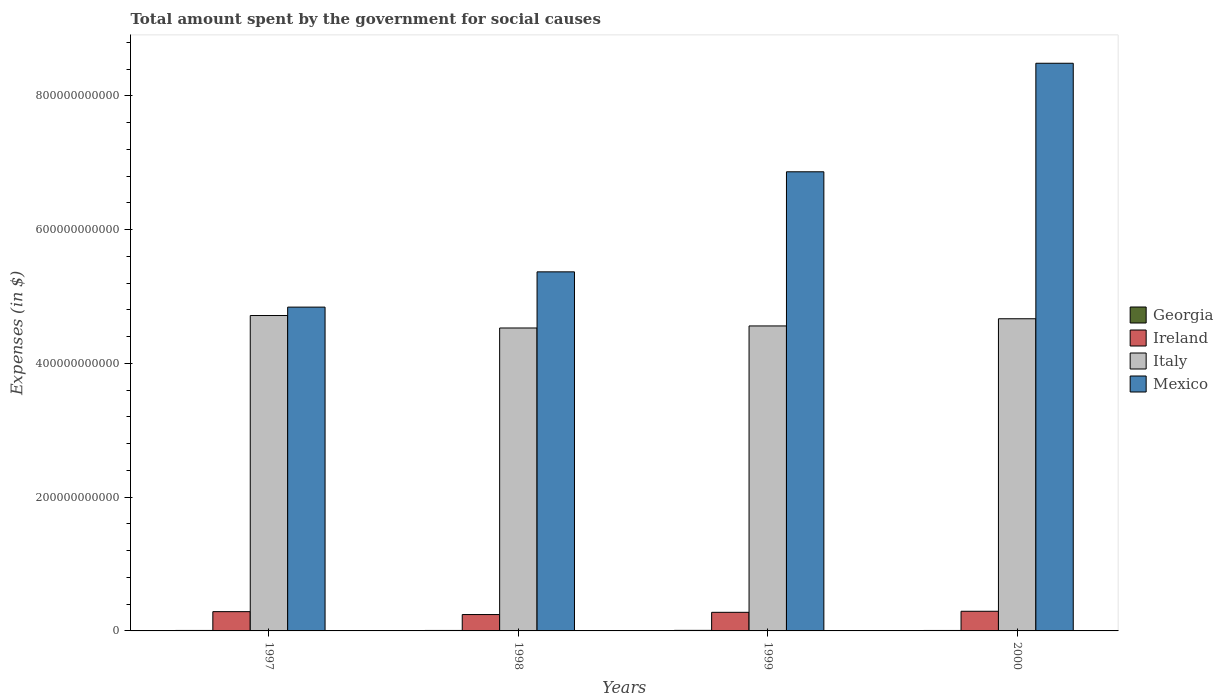How many different coloured bars are there?
Offer a very short reply. 4. How many groups of bars are there?
Offer a terse response. 4. How many bars are there on the 4th tick from the left?
Your response must be concise. 4. How many bars are there on the 3rd tick from the right?
Ensure brevity in your answer.  4. What is the label of the 1st group of bars from the left?
Your answer should be compact. 1997. In how many cases, is the number of bars for a given year not equal to the number of legend labels?
Provide a succinct answer. 0. What is the amount spent for social causes by the government in Italy in 1997?
Your answer should be compact. 4.72e+11. Across all years, what is the maximum amount spent for social causes by the government in Mexico?
Give a very brief answer. 8.49e+11. Across all years, what is the minimum amount spent for social causes by the government in Mexico?
Provide a succinct answer. 4.84e+11. In which year was the amount spent for social causes by the government in Ireland minimum?
Your response must be concise. 1998. What is the total amount spent for social causes by the government in Georgia in the graph?
Your answer should be very brief. 2.94e+09. What is the difference between the amount spent for social causes by the government in Italy in 1997 and that in 2000?
Offer a terse response. 4.85e+09. What is the difference between the amount spent for social causes by the government in Italy in 1998 and the amount spent for social causes by the government in Mexico in 1999?
Your answer should be compact. -2.34e+11. What is the average amount spent for social causes by the government in Georgia per year?
Offer a very short reply. 7.34e+08. In the year 2000, what is the difference between the amount spent for social causes by the government in Italy and amount spent for social causes by the government in Ireland?
Make the answer very short. 4.37e+11. In how many years, is the amount spent for social causes by the government in Italy greater than 40000000000 $?
Your answer should be compact. 4. What is the ratio of the amount spent for social causes by the government in Italy in 1997 to that in 1999?
Make the answer very short. 1.03. Is the amount spent for social causes by the government in Ireland in 1997 less than that in 1999?
Provide a succinct answer. No. Is the difference between the amount spent for social causes by the government in Italy in 1998 and 2000 greater than the difference between the amount spent for social causes by the government in Ireland in 1998 and 2000?
Provide a short and direct response. No. What is the difference between the highest and the second highest amount spent for social causes by the government in Mexico?
Keep it short and to the point. 1.62e+11. What is the difference between the highest and the lowest amount spent for social causes by the government in Mexico?
Offer a terse response. 3.65e+11. In how many years, is the amount spent for social causes by the government in Mexico greater than the average amount spent for social causes by the government in Mexico taken over all years?
Offer a very short reply. 2. What does the 3rd bar from the right in 1999 represents?
Your answer should be compact. Ireland. How many bars are there?
Provide a short and direct response. 16. Are all the bars in the graph horizontal?
Your answer should be very brief. No. How many years are there in the graph?
Make the answer very short. 4. What is the difference between two consecutive major ticks on the Y-axis?
Offer a terse response. 2.00e+11. Are the values on the major ticks of Y-axis written in scientific E-notation?
Offer a very short reply. No. Where does the legend appear in the graph?
Provide a succinct answer. Center right. How many legend labels are there?
Ensure brevity in your answer.  4. What is the title of the graph?
Offer a very short reply. Total amount spent by the government for social causes. What is the label or title of the X-axis?
Provide a succinct answer. Years. What is the label or title of the Y-axis?
Make the answer very short. Expenses (in $). What is the Expenses (in $) in Georgia in 1997?
Ensure brevity in your answer.  7.00e+08. What is the Expenses (in $) in Ireland in 1997?
Offer a very short reply. 2.88e+1. What is the Expenses (in $) in Italy in 1997?
Your answer should be compact. 4.72e+11. What is the Expenses (in $) of Mexico in 1997?
Your answer should be compact. 4.84e+11. What is the Expenses (in $) in Georgia in 1998?
Make the answer very short. 7.21e+08. What is the Expenses (in $) of Ireland in 1998?
Offer a very short reply. 2.45e+1. What is the Expenses (in $) in Italy in 1998?
Provide a succinct answer. 4.53e+11. What is the Expenses (in $) in Mexico in 1998?
Make the answer very short. 5.37e+11. What is the Expenses (in $) of Georgia in 1999?
Your response must be concise. 8.17e+08. What is the Expenses (in $) of Ireland in 1999?
Offer a terse response. 2.78e+1. What is the Expenses (in $) in Italy in 1999?
Your response must be concise. 4.56e+11. What is the Expenses (in $) in Mexico in 1999?
Ensure brevity in your answer.  6.86e+11. What is the Expenses (in $) in Georgia in 2000?
Keep it short and to the point. 6.98e+08. What is the Expenses (in $) in Ireland in 2000?
Your answer should be compact. 2.94e+1. What is the Expenses (in $) of Italy in 2000?
Your answer should be very brief. 4.67e+11. What is the Expenses (in $) in Mexico in 2000?
Keep it short and to the point. 8.49e+11. Across all years, what is the maximum Expenses (in $) in Georgia?
Provide a short and direct response. 8.17e+08. Across all years, what is the maximum Expenses (in $) of Ireland?
Your answer should be very brief. 2.94e+1. Across all years, what is the maximum Expenses (in $) of Italy?
Provide a succinct answer. 4.72e+11. Across all years, what is the maximum Expenses (in $) in Mexico?
Your response must be concise. 8.49e+11. Across all years, what is the minimum Expenses (in $) in Georgia?
Your response must be concise. 6.98e+08. Across all years, what is the minimum Expenses (in $) in Ireland?
Give a very brief answer. 2.45e+1. Across all years, what is the minimum Expenses (in $) of Italy?
Offer a terse response. 4.53e+11. Across all years, what is the minimum Expenses (in $) of Mexico?
Offer a very short reply. 4.84e+11. What is the total Expenses (in $) in Georgia in the graph?
Your answer should be compact. 2.94e+09. What is the total Expenses (in $) of Ireland in the graph?
Your answer should be compact. 1.10e+11. What is the total Expenses (in $) in Italy in the graph?
Make the answer very short. 1.85e+12. What is the total Expenses (in $) of Mexico in the graph?
Make the answer very short. 2.56e+12. What is the difference between the Expenses (in $) of Georgia in 1997 and that in 1998?
Offer a very short reply. -2.05e+07. What is the difference between the Expenses (in $) in Ireland in 1997 and that in 1998?
Your answer should be very brief. 4.35e+09. What is the difference between the Expenses (in $) of Italy in 1997 and that in 1998?
Make the answer very short. 1.86e+1. What is the difference between the Expenses (in $) in Mexico in 1997 and that in 1998?
Offer a very short reply. -5.27e+1. What is the difference between the Expenses (in $) in Georgia in 1997 and that in 1999?
Your response must be concise. -1.17e+08. What is the difference between the Expenses (in $) of Ireland in 1997 and that in 1999?
Offer a very short reply. 1.01e+09. What is the difference between the Expenses (in $) of Italy in 1997 and that in 1999?
Give a very brief answer. 1.56e+1. What is the difference between the Expenses (in $) in Mexico in 1997 and that in 1999?
Offer a very short reply. -2.02e+11. What is the difference between the Expenses (in $) in Georgia in 1997 and that in 2000?
Keep it short and to the point. 2.10e+06. What is the difference between the Expenses (in $) of Ireland in 1997 and that in 2000?
Provide a short and direct response. -5.45e+08. What is the difference between the Expenses (in $) of Italy in 1997 and that in 2000?
Your answer should be compact. 4.85e+09. What is the difference between the Expenses (in $) of Mexico in 1997 and that in 2000?
Give a very brief answer. -3.65e+11. What is the difference between the Expenses (in $) in Georgia in 1998 and that in 1999?
Keep it short and to the point. -9.62e+07. What is the difference between the Expenses (in $) of Ireland in 1998 and that in 1999?
Your answer should be very brief. -3.33e+09. What is the difference between the Expenses (in $) in Italy in 1998 and that in 1999?
Offer a terse response. -3.07e+09. What is the difference between the Expenses (in $) in Mexico in 1998 and that in 1999?
Make the answer very short. -1.50e+11. What is the difference between the Expenses (in $) of Georgia in 1998 and that in 2000?
Your answer should be compact. 2.26e+07. What is the difference between the Expenses (in $) in Ireland in 1998 and that in 2000?
Provide a short and direct response. -4.89e+09. What is the difference between the Expenses (in $) of Italy in 1998 and that in 2000?
Offer a terse response. -1.38e+1. What is the difference between the Expenses (in $) of Mexico in 1998 and that in 2000?
Provide a succinct answer. -3.12e+11. What is the difference between the Expenses (in $) in Georgia in 1999 and that in 2000?
Ensure brevity in your answer.  1.19e+08. What is the difference between the Expenses (in $) of Ireland in 1999 and that in 2000?
Your response must be concise. -1.56e+09. What is the difference between the Expenses (in $) in Italy in 1999 and that in 2000?
Provide a short and direct response. -1.07e+1. What is the difference between the Expenses (in $) in Mexico in 1999 and that in 2000?
Ensure brevity in your answer.  -1.62e+11. What is the difference between the Expenses (in $) in Georgia in 1997 and the Expenses (in $) in Ireland in 1998?
Your answer should be very brief. -2.38e+1. What is the difference between the Expenses (in $) of Georgia in 1997 and the Expenses (in $) of Italy in 1998?
Your response must be concise. -4.52e+11. What is the difference between the Expenses (in $) in Georgia in 1997 and the Expenses (in $) in Mexico in 1998?
Your answer should be very brief. -5.36e+11. What is the difference between the Expenses (in $) of Ireland in 1997 and the Expenses (in $) of Italy in 1998?
Ensure brevity in your answer.  -4.24e+11. What is the difference between the Expenses (in $) of Ireland in 1997 and the Expenses (in $) of Mexico in 1998?
Your response must be concise. -5.08e+11. What is the difference between the Expenses (in $) in Italy in 1997 and the Expenses (in $) in Mexico in 1998?
Provide a succinct answer. -6.53e+1. What is the difference between the Expenses (in $) in Georgia in 1997 and the Expenses (in $) in Ireland in 1999?
Keep it short and to the point. -2.71e+1. What is the difference between the Expenses (in $) of Georgia in 1997 and the Expenses (in $) of Italy in 1999?
Offer a very short reply. -4.55e+11. What is the difference between the Expenses (in $) of Georgia in 1997 and the Expenses (in $) of Mexico in 1999?
Provide a succinct answer. -6.86e+11. What is the difference between the Expenses (in $) in Ireland in 1997 and the Expenses (in $) in Italy in 1999?
Provide a succinct answer. -4.27e+11. What is the difference between the Expenses (in $) in Ireland in 1997 and the Expenses (in $) in Mexico in 1999?
Offer a terse response. -6.58e+11. What is the difference between the Expenses (in $) of Italy in 1997 and the Expenses (in $) of Mexico in 1999?
Offer a very short reply. -2.15e+11. What is the difference between the Expenses (in $) of Georgia in 1997 and the Expenses (in $) of Ireland in 2000?
Offer a very short reply. -2.87e+1. What is the difference between the Expenses (in $) of Georgia in 1997 and the Expenses (in $) of Italy in 2000?
Offer a very short reply. -4.66e+11. What is the difference between the Expenses (in $) in Georgia in 1997 and the Expenses (in $) in Mexico in 2000?
Provide a short and direct response. -8.48e+11. What is the difference between the Expenses (in $) of Ireland in 1997 and the Expenses (in $) of Italy in 2000?
Provide a short and direct response. -4.38e+11. What is the difference between the Expenses (in $) of Ireland in 1997 and the Expenses (in $) of Mexico in 2000?
Provide a short and direct response. -8.20e+11. What is the difference between the Expenses (in $) of Italy in 1997 and the Expenses (in $) of Mexico in 2000?
Make the answer very short. -3.77e+11. What is the difference between the Expenses (in $) in Georgia in 1998 and the Expenses (in $) in Ireland in 1999?
Ensure brevity in your answer.  -2.71e+1. What is the difference between the Expenses (in $) of Georgia in 1998 and the Expenses (in $) of Italy in 1999?
Give a very brief answer. -4.55e+11. What is the difference between the Expenses (in $) of Georgia in 1998 and the Expenses (in $) of Mexico in 1999?
Offer a terse response. -6.86e+11. What is the difference between the Expenses (in $) of Ireland in 1998 and the Expenses (in $) of Italy in 1999?
Make the answer very short. -4.32e+11. What is the difference between the Expenses (in $) in Ireland in 1998 and the Expenses (in $) in Mexico in 1999?
Provide a succinct answer. -6.62e+11. What is the difference between the Expenses (in $) of Italy in 1998 and the Expenses (in $) of Mexico in 1999?
Your response must be concise. -2.34e+11. What is the difference between the Expenses (in $) of Georgia in 1998 and the Expenses (in $) of Ireland in 2000?
Your answer should be compact. -2.87e+1. What is the difference between the Expenses (in $) in Georgia in 1998 and the Expenses (in $) in Italy in 2000?
Your answer should be compact. -4.66e+11. What is the difference between the Expenses (in $) of Georgia in 1998 and the Expenses (in $) of Mexico in 2000?
Offer a terse response. -8.48e+11. What is the difference between the Expenses (in $) of Ireland in 1998 and the Expenses (in $) of Italy in 2000?
Offer a terse response. -4.42e+11. What is the difference between the Expenses (in $) in Ireland in 1998 and the Expenses (in $) in Mexico in 2000?
Your answer should be very brief. -8.24e+11. What is the difference between the Expenses (in $) in Italy in 1998 and the Expenses (in $) in Mexico in 2000?
Provide a short and direct response. -3.96e+11. What is the difference between the Expenses (in $) of Georgia in 1999 and the Expenses (in $) of Ireland in 2000?
Provide a succinct answer. -2.86e+1. What is the difference between the Expenses (in $) of Georgia in 1999 and the Expenses (in $) of Italy in 2000?
Your response must be concise. -4.66e+11. What is the difference between the Expenses (in $) in Georgia in 1999 and the Expenses (in $) in Mexico in 2000?
Ensure brevity in your answer.  -8.48e+11. What is the difference between the Expenses (in $) in Ireland in 1999 and the Expenses (in $) in Italy in 2000?
Your response must be concise. -4.39e+11. What is the difference between the Expenses (in $) of Ireland in 1999 and the Expenses (in $) of Mexico in 2000?
Give a very brief answer. -8.21e+11. What is the difference between the Expenses (in $) of Italy in 1999 and the Expenses (in $) of Mexico in 2000?
Your answer should be very brief. -3.93e+11. What is the average Expenses (in $) in Georgia per year?
Offer a terse response. 7.34e+08. What is the average Expenses (in $) in Ireland per year?
Provide a succinct answer. 2.76e+1. What is the average Expenses (in $) in Italy per year?
Make the answer very short. 4.62e+11. What is the average Expenses (in $) in Mexico per year?
Make the answer very short. 6.39e+11. In the year 1997, what is the difference between the Expenses (in $) in Georgia and Expenses (in $) in Ireland?
Provide a succinct answer. -2.81e+1. In the year 1997, what is the difference between the Expenses (in $) in Georgia and Expenses (in $) in Italy?
Your answer should be compact. -4.71e+11. In the year 1997, what is the difference between the Expenses (in $) of Georgia and Expenses (in $) of Mexico?
Your response must be concise. -4.83e+11. In the year 1997, what is the difference between the Expenses (in $) of Ireland and Expenses (in $) of Italy?
Make the answer very short. -4.43e+11. In the year 1997, what is the difference between the Expenses (in $) of Ireland and Expenses (in $) of Mexico?
Keep it short and to the point. -4.55e+11. In the year 1997, what is the difference between the Expenses (in $) in Italy and Expenses (in $) in Mexico?
Ensure brevity in your answer.  -1.26e+1. In the year 1998, what is the difference between the Expenses (in $) of Georgia and Expenses (in $) of Ireland?
Your answer should be very brief. -2.38e+1. In the year 1998, what is the difference between the Expenses (in $) of Georgia and Expenses (in $) of Italy?
Ensure brevity in your answer.  -4.52e+11. In the year 1998, what is the difference between the Expenses (in $) in Georgia and Expenses (in $) in Mexico?
Offer a terse response. -5.36e+11. In the year 1998, what is the difference between the Expenses (in $) of Ireland and Expenses (in $) of Italy?
Provide a succinct answer. -4.28e+11. In the year 1998, what is the difference between the Expenses (in $) of Ireland and Expenses (in $) of Mexico?
Your answer should be very brief. -5.12e+11. In the year 1998, what is the difference between the Expenses (in $) of Italy and Expenses (in $) of Mexico?
Your answer should be compact. -8.39e+1. In the year 1999, what is the difference between the Expenses (in $) of Georgia and Expenses (in $) of Ireland?
Offer a terse response. -2.70e+1. In the year 1999, what is the difference between the Expenses (in $) in Georgia and Expenses (in $) in Italy?
Your answer should be compact. -4.55e+11. In the year 1999, what is the difference between the Expenses (in $) of Georgia and Expenses (in $) of Mexico?
Give a very brief answer. -6.86e+11. In the year 1999, what is the difference between the Expenses (in $) of Ireland and Expenses (in $) of Italy?
Provide a succinct answer. -4.28e+11. In the year 1999, what is the difference between the Expenses (in $) in Ireland and Expenses (in $) in Mexico?
Keep it short and to the point. -6.59e+11. In the year 1999, what is the difference between the Expenses (in $) in Italy and Expenses (in $) in Mexico?
Your answer should be very brief. -2.30e+11. In the year 2000, what is the difference between the Expenses (in $) in Georgia and Expenses (in $) in Ireland?
Keep it short and to the point. -2.87e+1. In the year 2000, what is the difference between the Expenses (in $) in Georgia and Expenses (in $) in Italy?
Offer a terse response. -4.66e+11. In the year 2000, what is the difference between the Expenses (in $) of Georgia and Expenses (in $) of Mexico?
Your answer should be compact. -8.48e+11. In the year 2000, what is the difference between the Expenses (in $) in Ireland and Expenses (in $) in Italy?
Offer a very short reply. -4.37e+11. In the year 2000, what is the difference between the Expenses (in $) in Ireland and Expenses (in $) in Mexico?
Your answer should be compact. -8.19e+11. In the year 2000, what is the difference between the Expenses (in $) of Italy and Expenses (in $) of Mexico?
Provide a short and direct response. -3.82e+11. What is the ratio of the Expenses (in $) of Georgia in 1997 to that in 1998?
Ensure brevity in your answer.  0.97. What is the ratio of the Expenses (in $) in Ireland in 1997 to that in 1998?
Your answer should be very brief. 1.18. What is the ratio of the Expenses (in $) in Italy in 1997 to that in 1998?
Give a very brief answer. 1.04. What is the ratio of the Expenses (in $) in Mexico in 1997 to that in 1998?
Make the answer very short. 0.9. What is the ratio of the Expenses (in $) in Georgia in 1997 to that in 1999?
Your answer should be very brief. 0.86. What is the ratio of the Expenses (in $) of Ireland in 1997 to that in 1999?
Ensure brevity in your answer.  1.04. What is the ratio of the Expenses (in $) of Italy in 1997 to that in 1999?
Your answer should be very brief. 1.03. What is the ratio of the Expenses (in $) of Mexico in 1997 to that in 1999?
Give a very brief answer. 0.71. What is the ratio of the Expenses (in $) in Georgia in 1997 to that in 2000?
Provide a succinct answer. 1. What is the ratio of the Expenses (in $) of Ireland in 1997 to that in 2000?
Make the answer very short. 0.98. What is the ratio of the Expenses (in $) of Italy in 1997 to that in 2000?
Keep it short and to the point. 1.01. What is the ratio of the Expenses (in $) of Mexico in 1997 to that in 2000?
Provide a short and direct response. 0.57. What is the ratio of the Expenses (in $) in Georgia in 1998 to that in 1999?
Make the answer very short. 0.88. What is the ratio of the Expenses (in $) of Ireland in 1998 to that in 1999?
Your answer should be compact. 0.88. What is the ratio of the Expenses (in $) in Mexico in 1998 to that in 1999?
Make the answer very short. 0.78. What is the ratio of the Expenses (in $) in Georgia in 1998 to that in 2000?
Ensure brevity in your answer.  1.03. What is the ratio of the Expenses (in $) in Ireland in 1998 to that in 2000?
Keep it short and to the point. 0.83. What is the ratio of the Expenses (in $) in Italy in 1998 to that in 2000?
Your response must be concise. 0.97. What is the ratio of the Expenses (in $) in Mexico in 1998 to that in 2000?
Your answer should be compact. 0.63. What is the ratio of the Expenses (in $) of Georgia in 1999 to that in 2000?
Your answer should be very brief. 1.17. What is the ratio of the Expenses (in $) in Ireland in 1999 to that in 2000?
Provide a short and direct response. 0.95. What is the ratio of the Expenses (in $) in Mexico in 1999 to that in 2000?
Offer a terse response. 0.81. What is the difference between the highest and the second highest Expenses (in $) in Georgia?
Offer a very short reply. 9.62e+07. What is the difference between the highest and the second highest Expenses (in $) of Ireland?
Ensure brevity in your answer.  5.45e+08. What is the difference between the highest and the second highest Expenses (in $) of Italy?
Offer a very short reply. 4.85e+09. What is the difference between the highest and the second highest Expenses (in $) of Mexico?
Your answer should be compact. 1.62e+11. What is the difference between the highest and the lowest Expenses (in $) in Georgia?
Give a very brief answer. 1.19e+08. What is the difference between the highest and the lowest Expenses (in $) of Ireland?
Offer a very short reply. 4.89e+09. What is the difference between the highest and the lowest Expenses (in $) in Italy?
Offer a very short reply. 1.86e+1. What is the difference between the highest and the lowest Expenses (in $) of Mexico?
Your answer should be compact. 3.65e+11. 